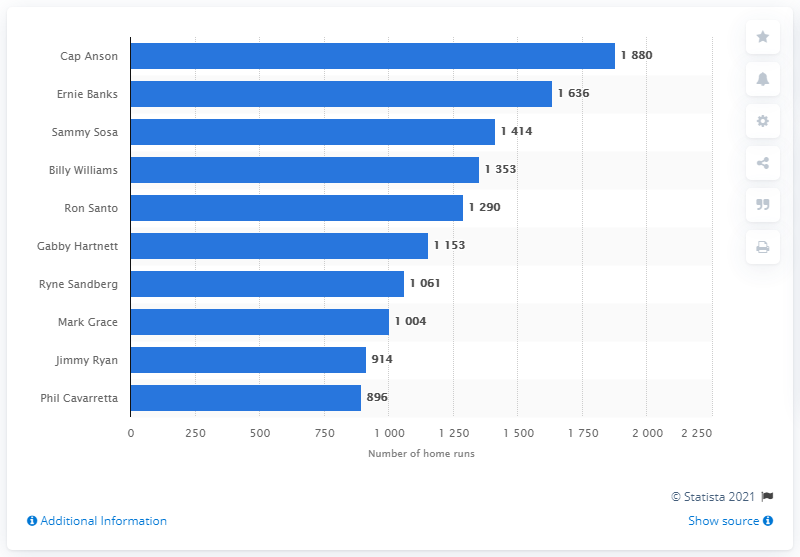Specify some key components in this picture. The Chicago Cubs franchise records show that Cap Anson holds the distinction of having the most RBI in the team's history with a total of xxx RBI. 